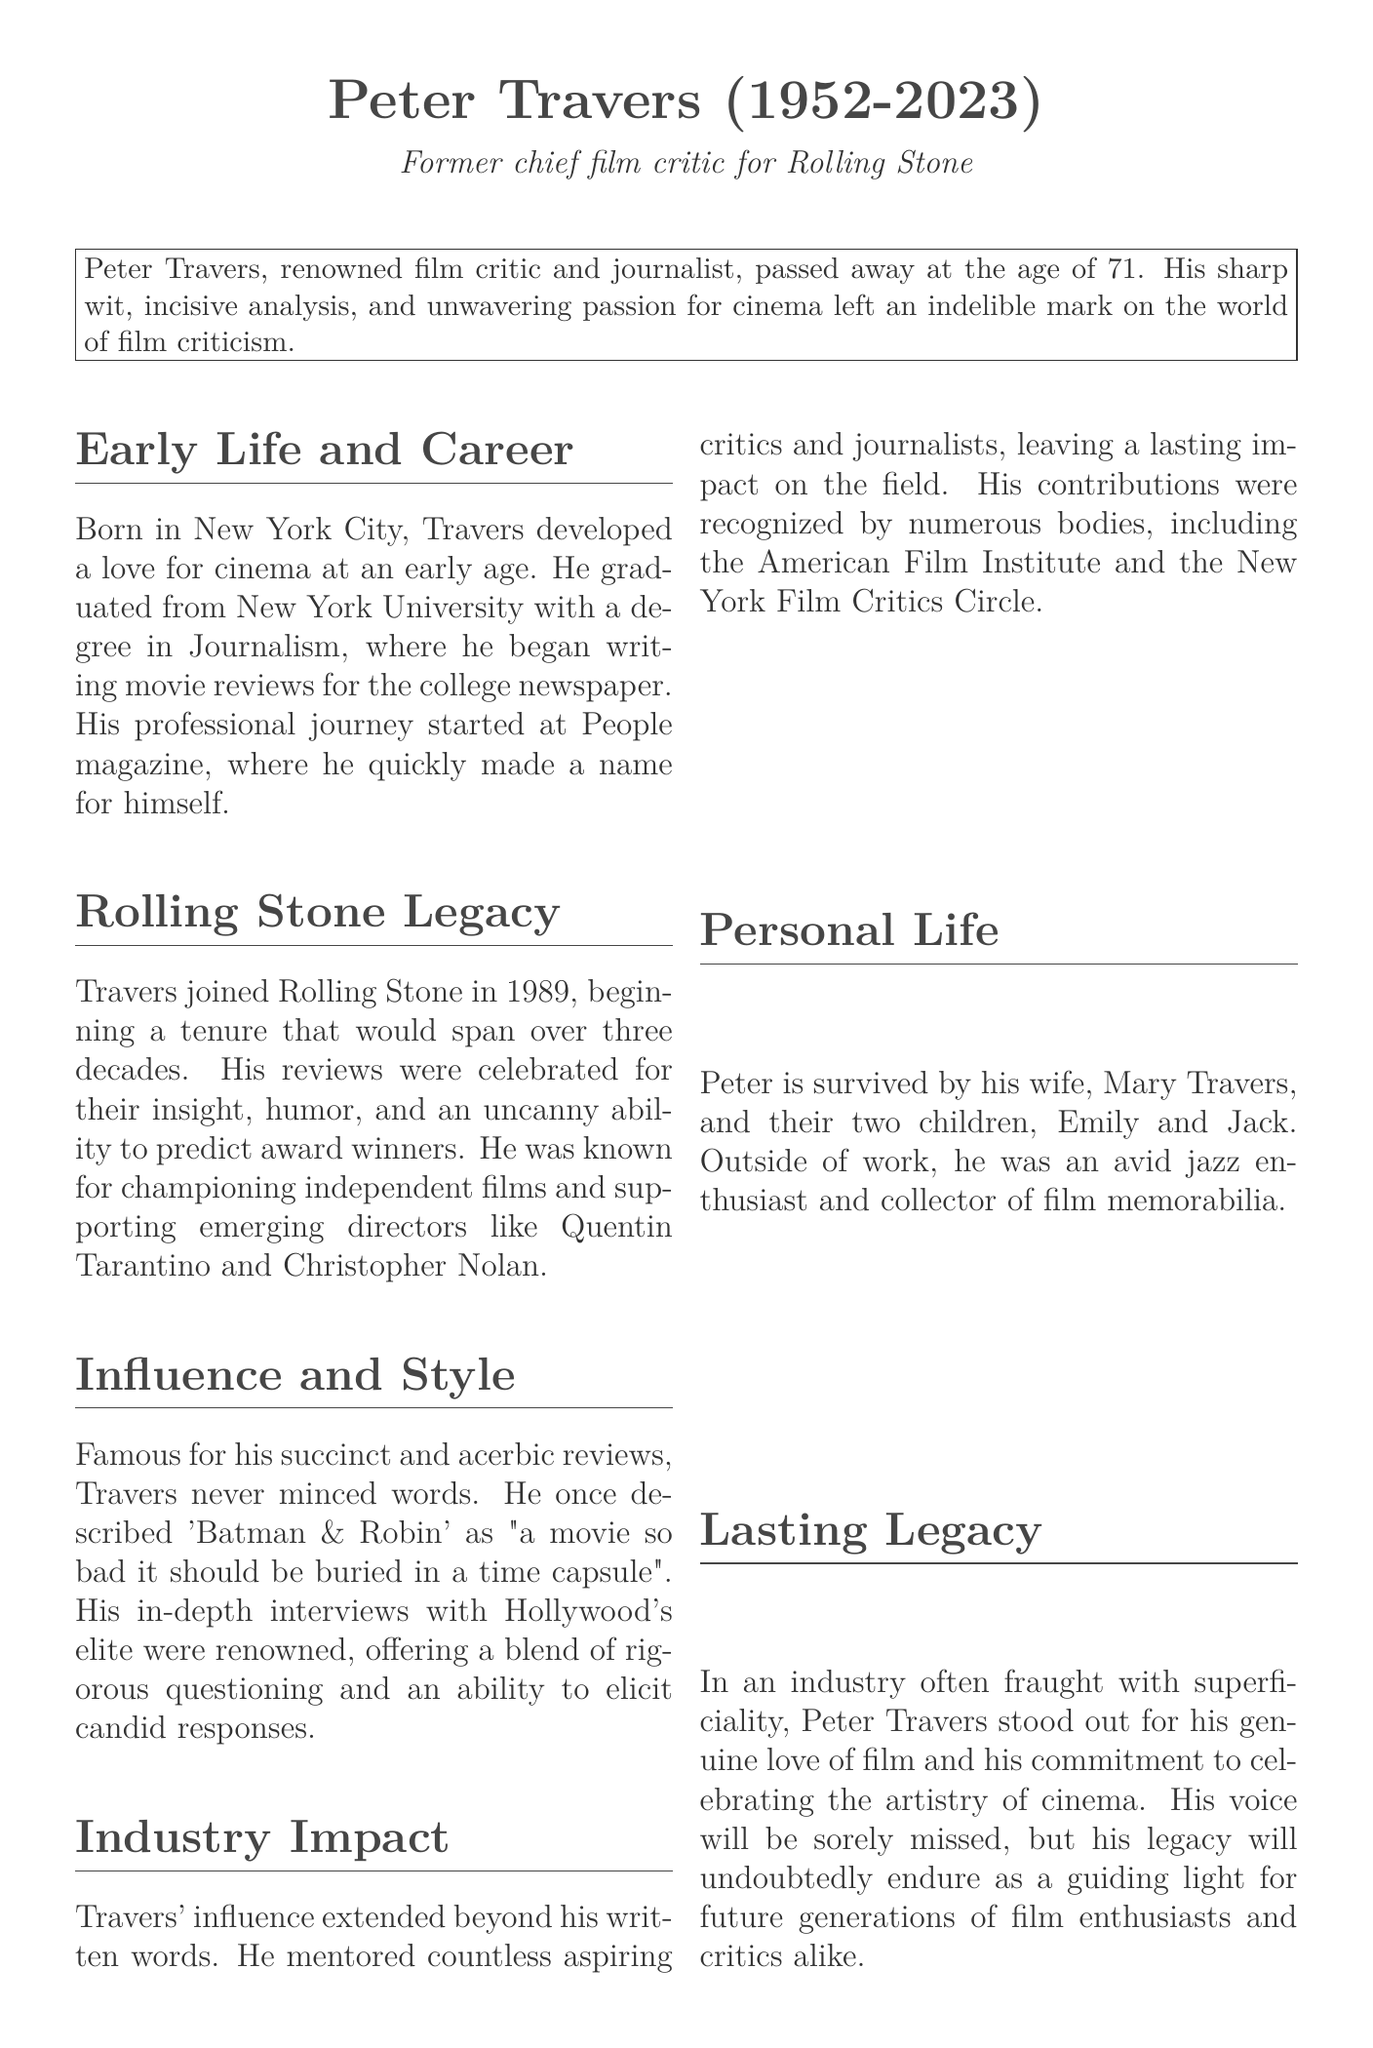What year was Peter Travers born? The document states that Peter Travers was born in 1952.
Answer: 1952 What was Peter Travers' role at Rolling Stone? The document describes him as the former chief film critic for Rolling Stone.
Answer: Chief film critic How many years did Travers write for Rolling Stone? The document mentions his tenure at Rolling Stone spanned over three decades.
Answer: Over three decades Who is one director Travers is known for supporting? The document notes that he supported emerging directors like Quentin Tarantino.
Answer: Quentin Tarantino What kind of films did Travers champion? The document states that he was known for championing independent films.
Answer: Independent films What was Peter Travers' age at the time of his passing? The document specifies that he passed away at the age of 71.
Answer: 71 What personal interest did Travers have outside of work? The document says he was an avid jazz enthusiast.
Answer: Jazz What impact did Travers have on aspiring critics? According to the document, he mentored countless aspiring critics and journalists.
Answer: Mentored aspiring critics What phrase did Travers use to describe the movie-going experience? The document includes his quote about movies being "the most astonishing act of collective pleasure."
Answer: Collective pleasure 